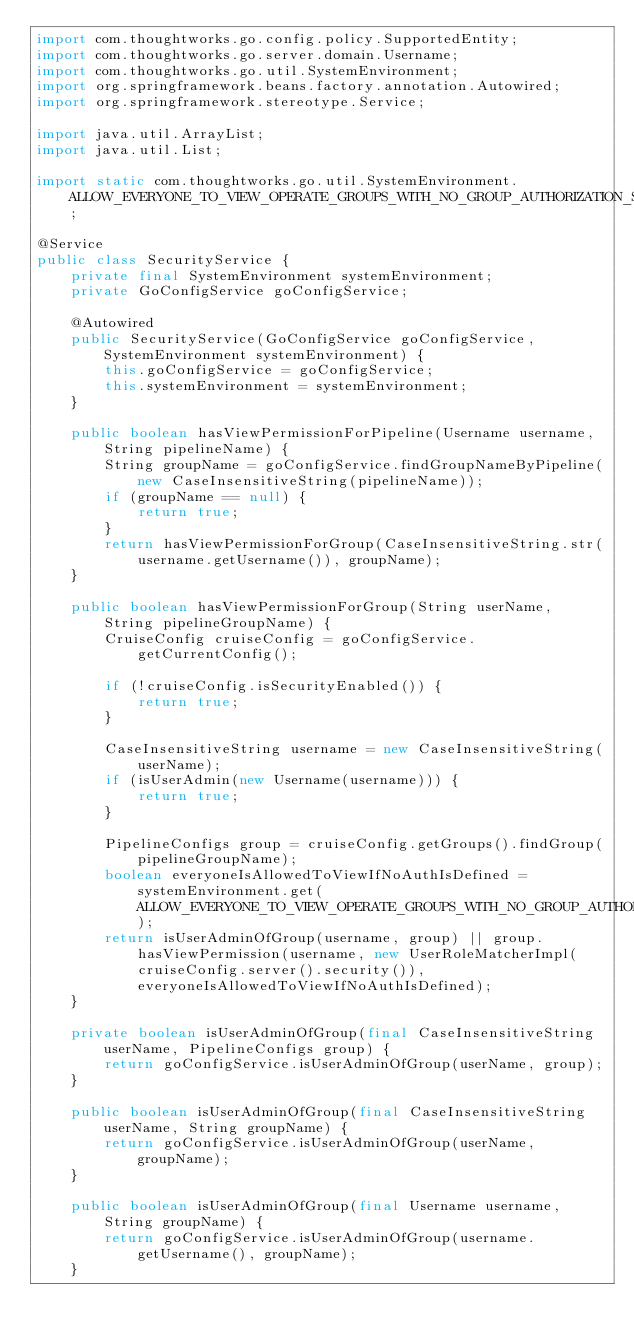<code> <loc_0><loc_0><loc_500><loc_500><_Java_>import com.thoughtworks.go.config.policy.SupportedEntity;
import com.thoughtworks.go.server.domain.Username;
import com.thoughtworks.go.util.SystemEnvironment;
import org.springframework.beans.factory.annotation.Autowired;
import org.springframework.stereotype.Service;

import java.util.ArrayList;
import java.util.List;

import static com.thoughtworks.go.util.SystemEnvironment.ALLOW_EVERYONE_TO_VIEW_OPERATE_GROUPS_WITH_NO_GROUP_AUTHORIZATION_SETUP;

@Service
public class SecurityService {
    private final SystemEnvironment systemEnvironment;
    private GoConfigService goConfigService;

    @Autowired
    public SecurityService(GoConfigService goConfigService, SystemEnvironment systemEnvironment) {
        this.goConfigService = goConfigService;
        this.systemEnvironment = systemEnvironment;
    }

    public boolean hasViewPermissionForPipeline(Username username, String pipelineName) {
        String groupName = goConfigService.findGroupNameByPipeline(new CaseInsensitiveString(pipelineName));
        if (groupName == null) {
            return true;
        }
        return hasViewPermissionForGroup(CaseInsensitiveString.str(username.getUsername()), groupName);
    }

    public boolean hasViewPermissionForGroup(String userName, String pipelineGroupName) {
        CruiseConfig cruiseConfig = goConfigService.getCurrentConfig();

        if (!cruiseConfig.isSecurityEnabled()) {
            return true;
        }

        CaseInsensitiveString username = new CaseInsensitiveString(userName);
        if (isUserAdmin(new Username(username))) {
            return true;
        }

        PipelineConfigs group = cruiseConfig.getGroups().findGroup(pipelineGroupName);
        boolean everyoneIsAllowedToViewIfNoAuthIsDefined = systemEnvironment.get(ALLOW_EVERYONE_TO_VIEW_OPERATE_GROUPS_WITH_NO_GROUP_AUTHORIZATION_SETUP);
        return isUserAdminOfGroup(username, group) || group.hasViewPermission(username, new UserRoleMatcherImpl(cruiseConfig.server().security()), everyoneIsAllowedToViewIfNoAuthIsDefined);
    }

    private boolean isUserAdminOfGroup(final CaseInsensitiveString userName, PipelineConfigs group) {
        return goConfigService.isUserAdminOfGroup(userName, group);
    }

    public boolean isUserAdminOfGroup(final CaseInsensitiveString userName, String groupName) {
        return goConfigService.isUserAdminOfGroup(userName, groupName);
    }

    public boolean isUserAdminOfGroup(final Username username, String groupName) {
        return goConfigService.isUserAdminOfGroup(username.getUsername(), groupName);
    }
</code> 